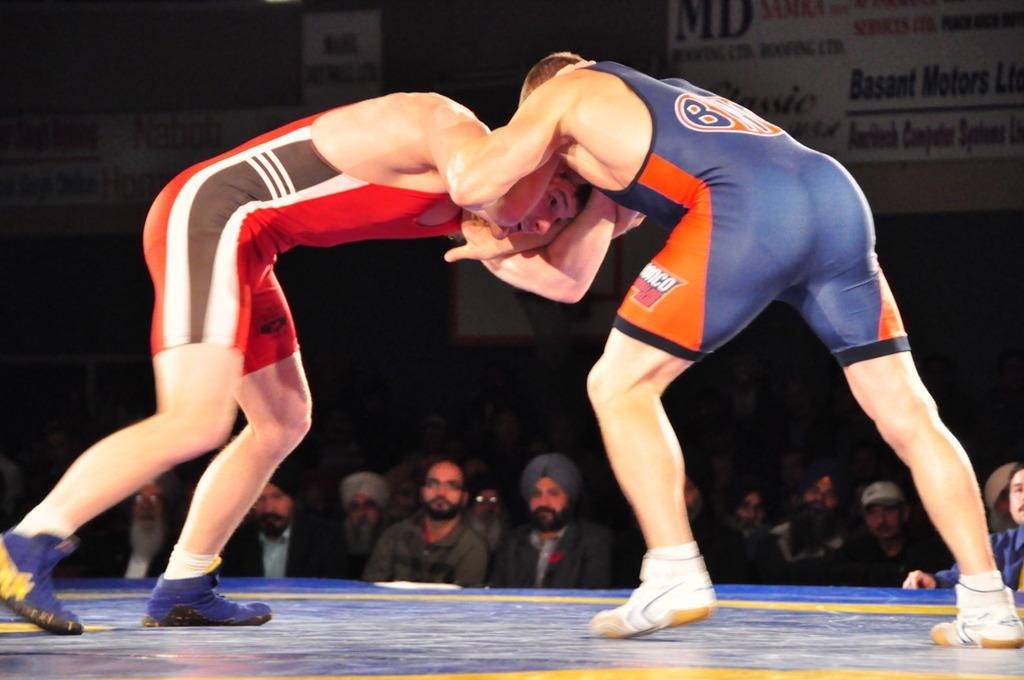<image>
Present a compact description of the photo's key features. The man in the blue and orange wrestling outfit had a B on it. 